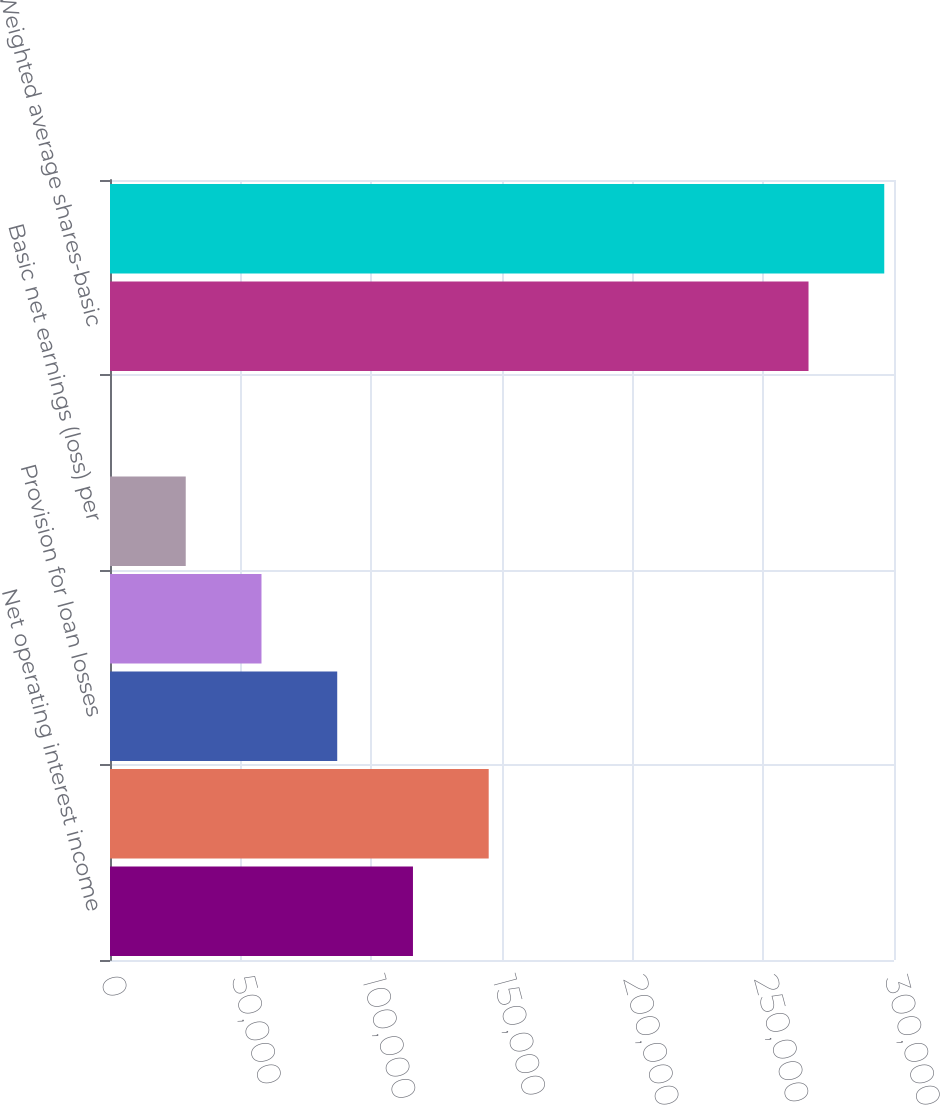Convert chart to OTSL. <chart><loc_0><loc_0><loc_500><loc_500><bar_chart><fcel>Net operating interest income<fcel>Total net revenue<fcel>Provision for loan losses<fcel>Net income (loss)<fcel>Basic net earnings (loss) per<fcel>Diluted net earnings (loss)<fcel>Weighted average shares-basic<fcel>Weighted average<nl><fcel>115929<fcel>144911<fcel>86947<fcel>57964.8<fcel>28982.7<fcel>0.54<fcel>267291<fcel>296273<nl></chart> 